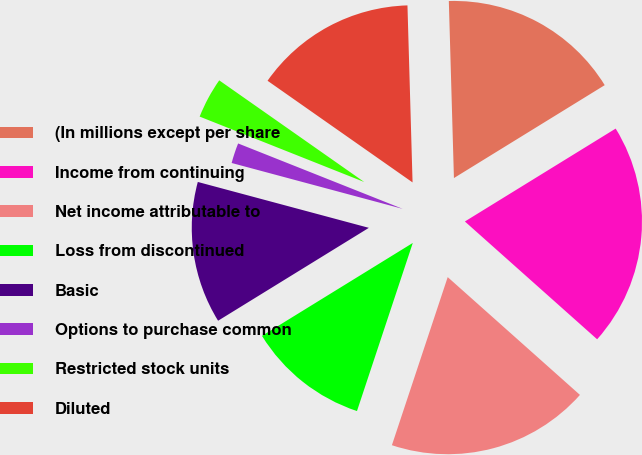<chart> <loc_0><loc_0><loc_500><loc_500><pie_chart><fcel>(In millions except per share<fcel>Income from continuing<fcel>Net income attributable to<fcel>Loss from discontinued<fcel>Basic<fcel>Options to purchase common<fcel>Restricted stock units<fcel>Diluted<nl><fcel>16.67%<fcel>20.37%<fcel>18.52%<fcel>11.11%<fcel>12.96%<fcel>1.85%<fcel>3.71%<fcel>14.81%<nl></chart> 